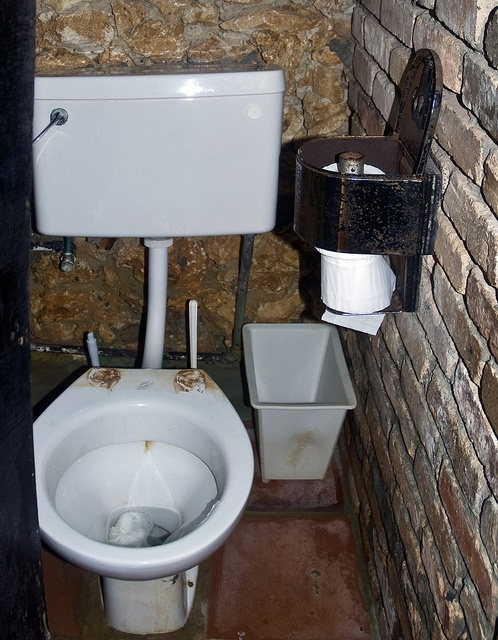Describe the objects in this image and their specific colors. I can see a toilet in black, darkgray, and lightgray tones in this image. 